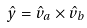<formula> <loc_0><loc_0><loc_500><loc_500>\hat { y } = \hat { v } _ { a } \times \hat { v } _ { b }</formula> 